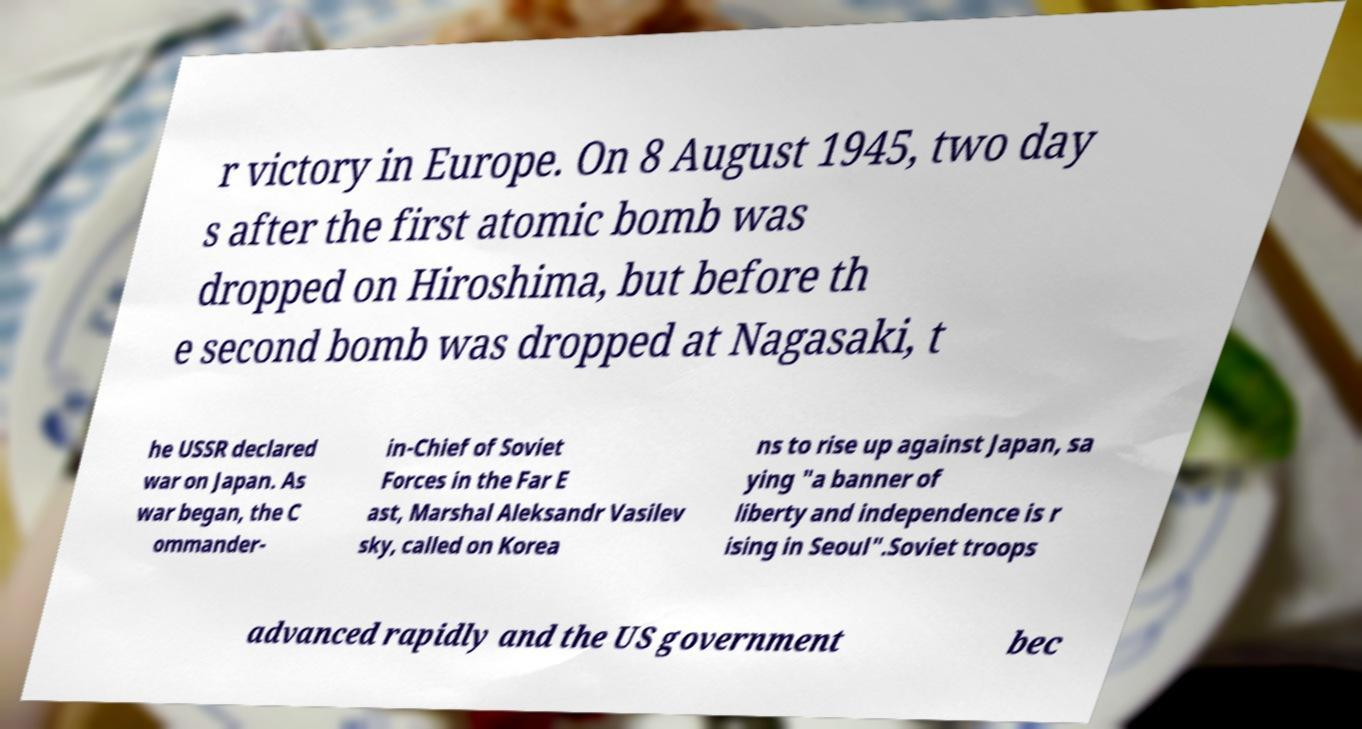For documentation purposes, I need the text within this image transcribed. Could you provide that? r victory in Europe. On 8 August 1945, two day s after the first atomic bomb was dropped on Hiroshima, but before th e second bomb was dropped at Nagasaki, t he USSR declared war on Japan. As war began, the C ommander- in-Chief of Soviet Forces in the Far E ast, Marshal Aleksandr Vasilev sky, called on Korea ns to rise up against Japan, sa ying "a banner of liberty and independence is r ising in Seoul".Soviet troops advanced rapidly and the US government bec 